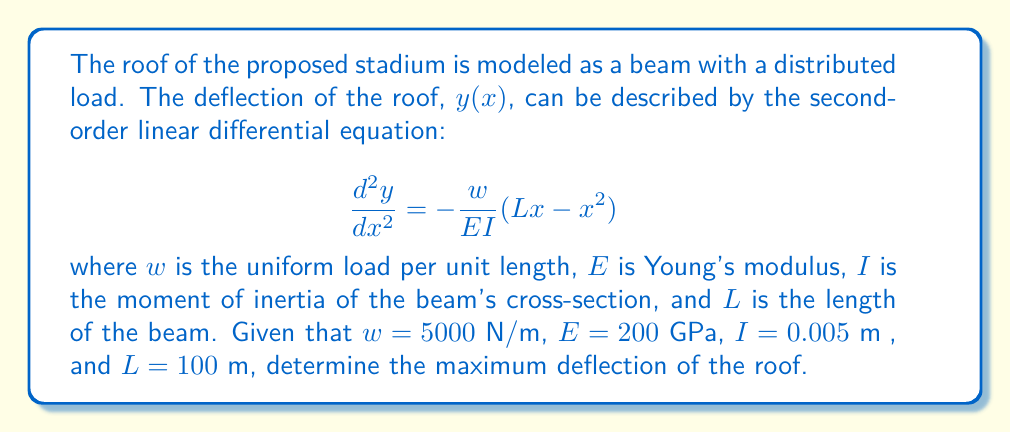Show me your answer to this math problem. To solve this problem, we need to follow these steps:

1) First, we integrate the given equation twice to find the general solution for $y(x)$:

   $$\frac{dy}{dx} = -\frac{w}{EI}(\frac{Lx^2}{2} - \frac{x^3}{3}) + C_1$$

   $$y(x) = -\frac{w}{EI}(\frac{Lx^3}{6} - \frac{x^4}{12}) + C_1x + C_2$$

2) We need to determine the constants $C_1$ and $C_2$ using boundary conditions. For a simply supported beam:

   At $x = 0$, $y = 0$: This gives us $C_2 = 0$
   At $x = L$, $y = 0$: This gives us $C_1 = \frac{wL^3}{24EI}$

3) Substituting these back into our equation for $y(x)$:

   $$y(x) = \frac{w}{EI}(\frac{Lx^3}{6} - \frac{x^4}{24} - \frac{L^3x}{24})$$

4) To find the maximum deflection, we need to find where $\frac{dy}{dx} = 0$:

   $$\frac{dy}{dx} = \frac{w}{EI}(\frac{Lx^2}{2} - \frac{x^3}{6} - \frac{L^3}{24}) = 0$$

   Solving this equation gives us $x = \frac{L}{2}$

5) The maximum deflection occurs at the midpoint of the beam. We can find its value by substituting $x = \frac{L}{2}$ into our equation for $y(x)$:

   $$y_{max} = \frac{5wL^4}{384EI}$$

6) Now we can substitute our given values:

   $w = 5000$ N/m
   $E = 200 \times 10^9$ Pa
   $I = 0.005$ m⁴
   $L = 100$ m

   $$y_{max} = \frac{5 \times 5000 \times 100^4}{384 \times 200 \times 10^9 \times 0.005} = 0.1628 \text{ m}$$

Therefore, the maximum deflection of the roof is approximately 0.1628 meters or 16.28 cm.
Answer: The maximum deflection of the stadium roof is 0.1628 meters. 